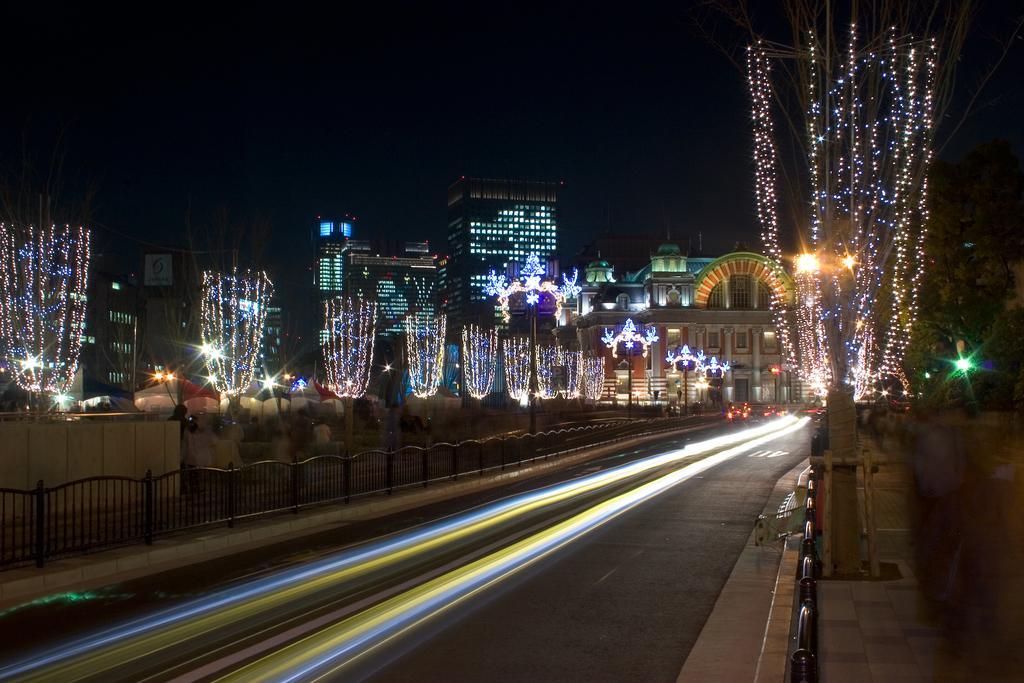Can you describe this image briefly? In this image there is a road, there are vehicles on the road, on the either side of the road there is pavement with metal fence, in the background of the image there are buildings decorated with lights. 